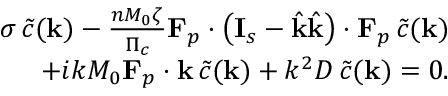<formula> <loc_0><loc_0><loc_500><loc_500>\begin{array} { r } { \sigma \, \tilde { c } ( k ) - \frac { n M _ { 0 } \zeta } { \Pi _ { c } } F _ { p } \cdot \left ( I _ { s } - \hat { k } \hat { k } \right ) \cdot F _ { p } \, \tilde { c } ( k ) } \\ { + i k M _ { 0 } F _ { p } \cdot k \, \tilde { c } ( k ) + k ^ { 2 } D \, \tilde { c } ( k ) = 0 . } \end{array}</formula> 